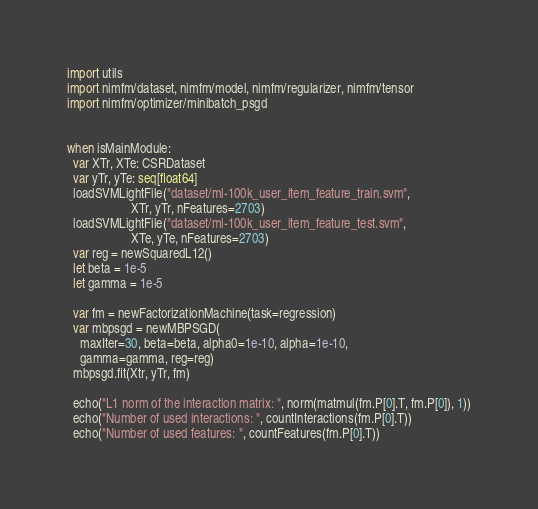<code> <loc_0><loc_0><loc_500><loc_500><_Nim_>import utils
import nimfm/dataset, nimfm/model, nimfm/regularizer, nimfm/tensor
import nimfm/optimizer/minibatch_psgd


when isMainModule:
  var XTr, XTe: CSRDataset
  var yTr, yTe: seq[float64]
  loadSVMLightFile("dataset/ml-100k_user_item_feature_train.svm",
                    XTr, yTr, nFeatures=2703)
  loadSVMLightFile("dataset/ml-100k_user_item_feature_test.svm",
                    XTe, yTe, nFeatures=2703)
  var reg = newSquaredL12()
  let beta = 1e-5
  let gamma = 1e-5

  var fm = newFactorizationMachine(task=regression)
  var mbpsgd = newMBPSGD(
    maxIter=30, beta=beta, alpha0=1e-10, alpha=1e-10,
    gamma=gamma, reg=reg)
  mbpsgd.fit(Xtr, yTr, fm)

  echo("L1 norm of the interaction matrix: ", norm(matmul(fm.P[0].T, fm.P[0]), 1))
  echo("Number of used interactions: ", countInteractions(fm.P[0].T))
  echo("Number of used features: ", countFeatures(fm.P[0].T))</code> 